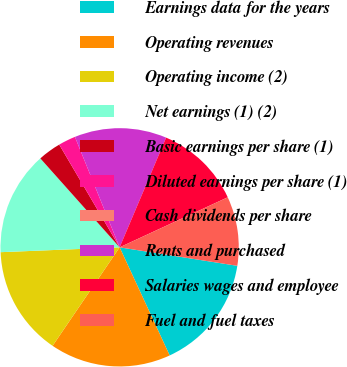<chart> <loc_0><loc_0><loc_500><loc_500><pie_chart><fcel>Earnings data for the years<fcel>Operating revenues<fcel>Operating income (2)<fcel>Net earnings (1) (2)<fcel>Basic earnings per share (1)<fcel>Diluted earnings per share (1)<fcel>Cash dividends per share<fcel>Rents and purchased<fcel>Salaries wages and employee<fcel>Fuel and fuel taxes<nl><fcel>15.62%<fcel>16.41%<fcel>14.84%<fcel>14.06%<fcel>3.13%<fcel>2.34%<fcel>0.0%<fcel>12.5%<fcel>11.72%<fcel>9.38%<nl></chart> 